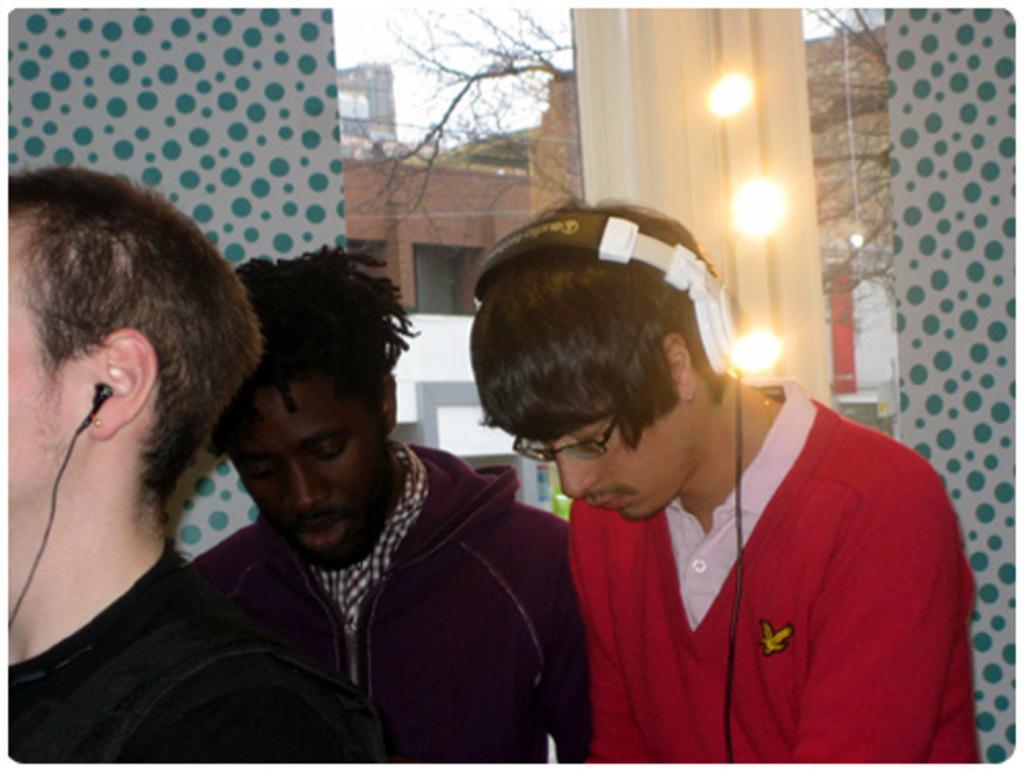Please provide a concise description of this image. This picture seems to be clicked inside the room. In the foreground we can see the group of people seems to be standing and we can see the headphone and the lights and some other items. In the background we can see the sky, dry stems and the buildings. 